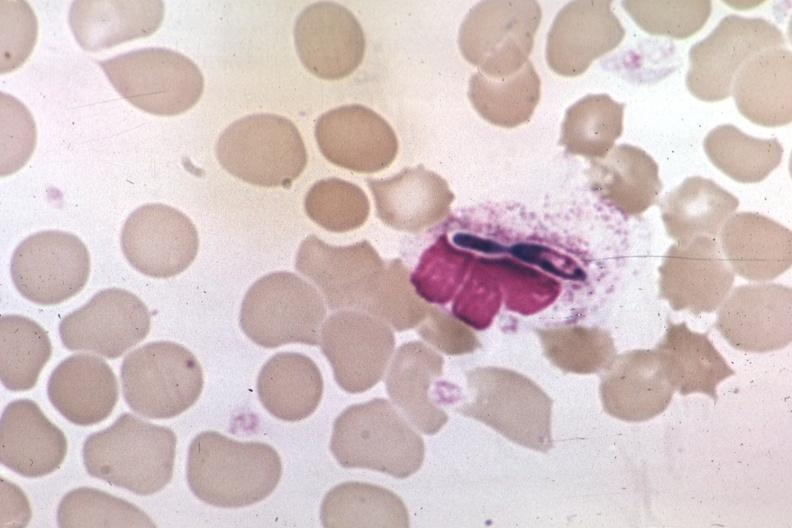s infarcts present?
Answer the question using a single word or phrase. No 